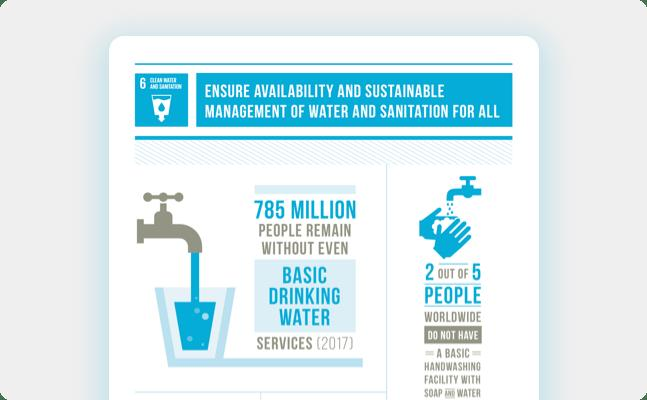Draw attention to some important aspects in this diagram. According to recent statistics, approximately 40% of people worldwide do not have access to a basic handwashing facility. Approximately 785 million people lack access to basic drinking water services. In the world, approximately 2 out of 5 people do not have access to proper handwashing facilities, which poses a significant health risk and hinders the progress of hygiene and sanitation efforts. 